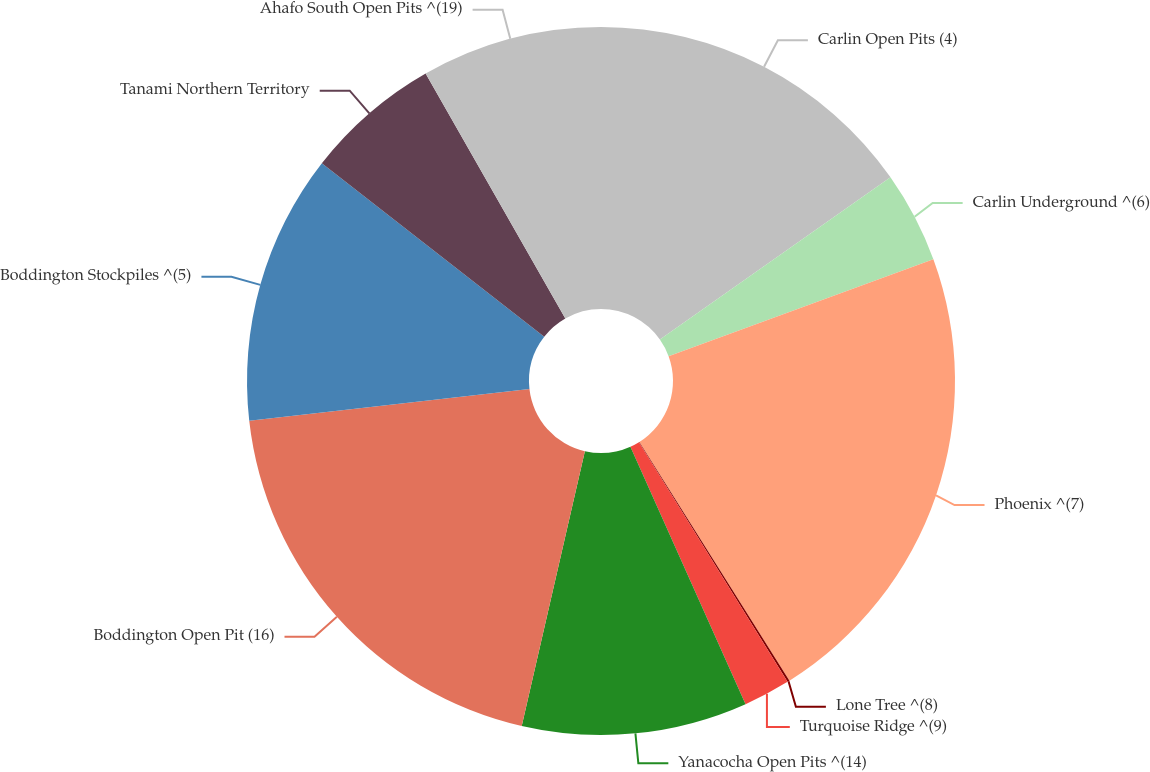<chart> <loc_0><loc_0><loc_500><loc_500><pie_chart><fcel>Carlin Open Pits (4)<fcel>Carlin Underground ^(6)<fcel>Phoenix ^(7)<fcel>Lone Tree ^(8)<fcel>Turquoise Ridge ^(9)<fcel>Yanacocha Open Pits ^(14)<fcel>Boddington Open Pit (16)<fcel>Boddington Stockpiles ^(5)<fcel>Tanami Northern Territory<fcel>Ahafo South Open Pits ^(19)<nl><fcel>15.24%<fcel>4.17%<fcel>21.66%<fcel>0.1%<fcel>2.14%<fcel>10.29%<fcel>19.62%<fcel>12.33%<fcel>6.21%<fcel>8.25%<nl></chart> 